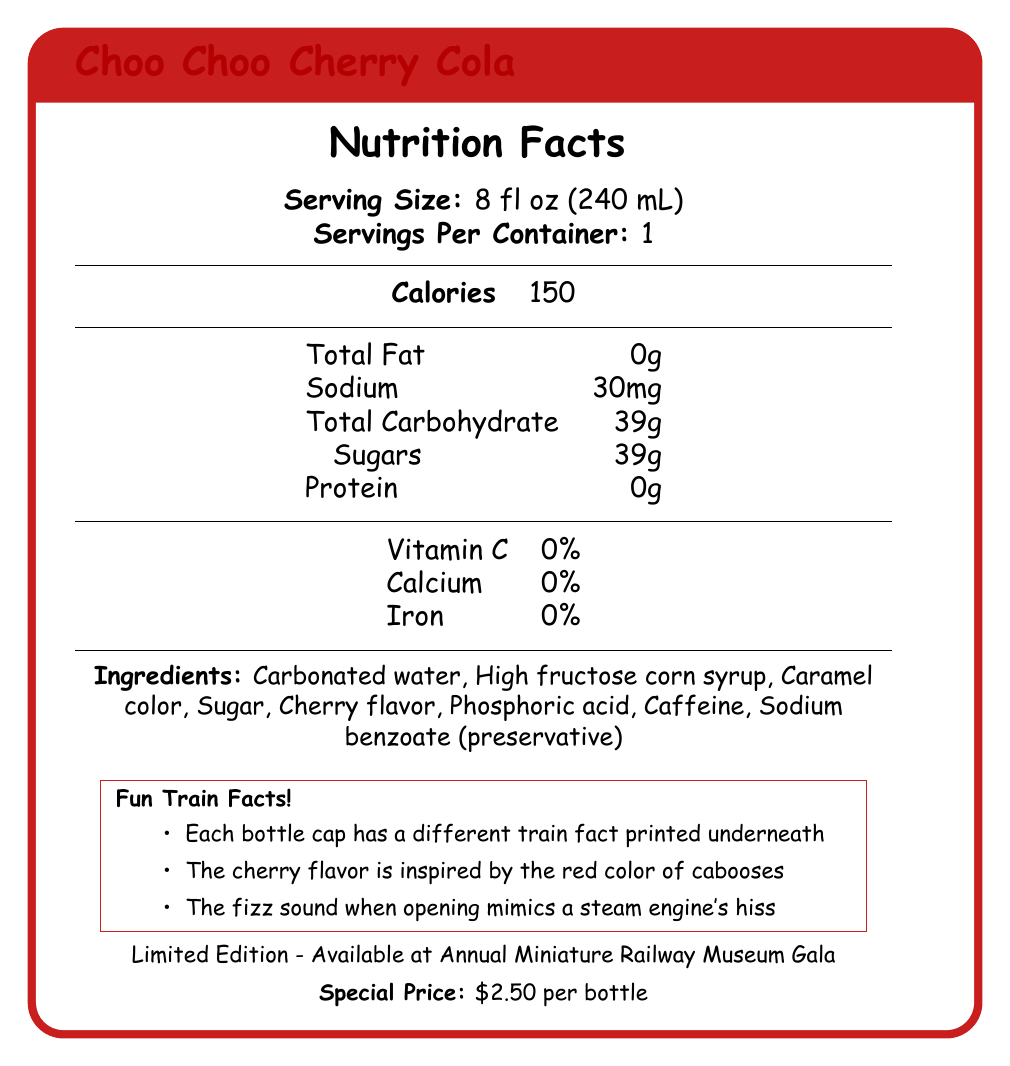what is the serving size? The serving size is clearly mentioned at the beginning of the Nutrition Facts section.
Answer: 8 fl oz (240 mL) how many total calories are in a serving? The total calorie content is listed under the Calories heading.
Answer: 150 what ingredients are used in Choo Choo Cherry Cola? The ingredients are enumerated in the Ingredients section of the document.
Answer: Carbonated water, High fructose corn syrup, Caramel color, Sugar, Cherry flavor, Phosphoric acid, Caffeine, Sodium benzoate (preservative) how much sugar is in one serving? The sugar content is listed under Total Carbohydrate in the detailed nutritional information.
Answer: 39g what is the special price per bottle? The special price is provided at the bottom of the document.
Answer: $2.50 per bottle what is the container type of Choo Choo Cherry Cola? A. Plastic bottle B. Glass bottle C. Can D. Carton The container is specified as a glass bottle in the packaging details section.
Answer: B. Glass bottle what is the shape of the bottle? A. Straight B. Square C. Contour D. Cylinder The bottle shape is described as a classic contour in the packaging details section.
Answer: C. Contour is there protein in Choo Choo Cherry Cola? (Yes/No) The protein content is listed as 0g in the nutritional information section.
Answer: No are there any vitamins or minerals in Choo Choo Cherry Cola? The document shows 0% for Vitamin C, Calcium, and Iron.
Answer: No describe in detail what makes Choo Choo Cherry Cola nostalgic. The nostalgic elements are spread across packaging details and nostalgic features sections, including visual design elements, collectible bottle series, QR code linking, and fun details like train facts and bottle opener design.
Answer: Choo Choo Cherry Cola features a classic contour glass bottle with raised glass lettering, a paper label with faux aging, and 1950s-style typography. It also has a QR code linking to a virtual model train exhibition and a collectible bottle series featuring different model train engines. Additionally, each bottle cap has a different train fact printed underneath, and the bottle opener is shaped like a miniature railroad spike. what is the inspiration behind the cherry flavor? The inspiration for the cherry flavor is mentioned in the fun train facts section.
Answer: The red color of cabooses can the nutritional content of Choo Choo Cherry Cola be considered healthy? Determining whether the nutritional content is healthy requires more context such as dietary guidelines or comparison with standard recommended values, which is not provided in the document.
Answer: Not enough information 